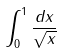Convert formula to latex. <formula><loc_0><loc_0><loc_500><loc_500>\int _ { 0 } ^ { 1 } \frac { d x } { \sqrt { x } }</formula> 